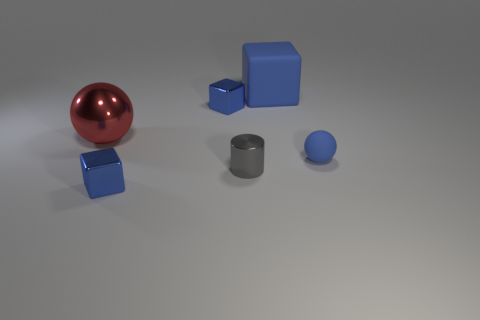Subtract all tiny blue blocks. How many blocks are left? 1 Add 2 small yellow matte balls. How many objects exist? 8 Subtract all red balls. How many balls are left? 1 Subtract all spheres. How many objects are left? 4 Subtract all yellow cubes. Subtract all yellow cylinders. How many cubes are left? 3 Subtract all red spheres. How many blue cylinders are left? 0 Subtract all big cyan balls. Subtract all matte cubes. How many objects are left? 5 Add 5 tiny matte spheres. How many tiny matte spheres are left? 6 Add 1 big brown shiny cubes. How many big brown shiny cubes exist? 1 Subtract 1 gray cylinders. How many objects are left? 5 